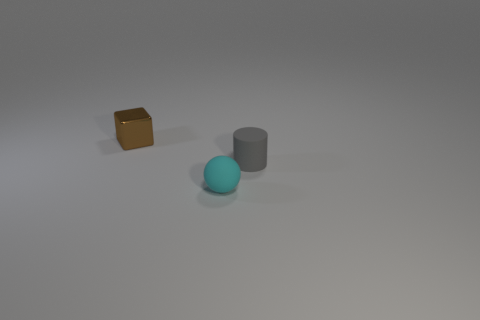There is a thing that is on the right side of the small brown metallic block and behind the rubber sphere; what is its color?
Provide a succinct answer. Gray. The matte thing that is to the left of the cylinder has what shape?
Your response must be concise. Sphere. There is a thing right of the matte object in front of the matte thing that is behind the cyan sphere; how big is it?
Give a very brief answer. Small. What number of cyan rubber things are right of the thing behind the tiny gray matte cylinder?
Provide a succinct answer. 1. What size is the object that is both behind the small rubber sphere and in front of the tiny brown metal block?
Offer a terse response. Small. What number of matte things are small balls or gray things?
Offer a very short reply. 2. What material is the ball?
Offer a very short reply. Rubber. The thing that is on the left side of the rubber thing that is to the left of the small gray matte object that is on the right side of the ball is made of what material?
Provide a short and direct response. Metal. There is a brown shiny thing that is the same size as the gray matte thing; what is its shape?
Your answer should be compact. Cube. What number of objects are either brown metal blocks or things right of the metallic block?
Ensure brevity in your answer.  3. 